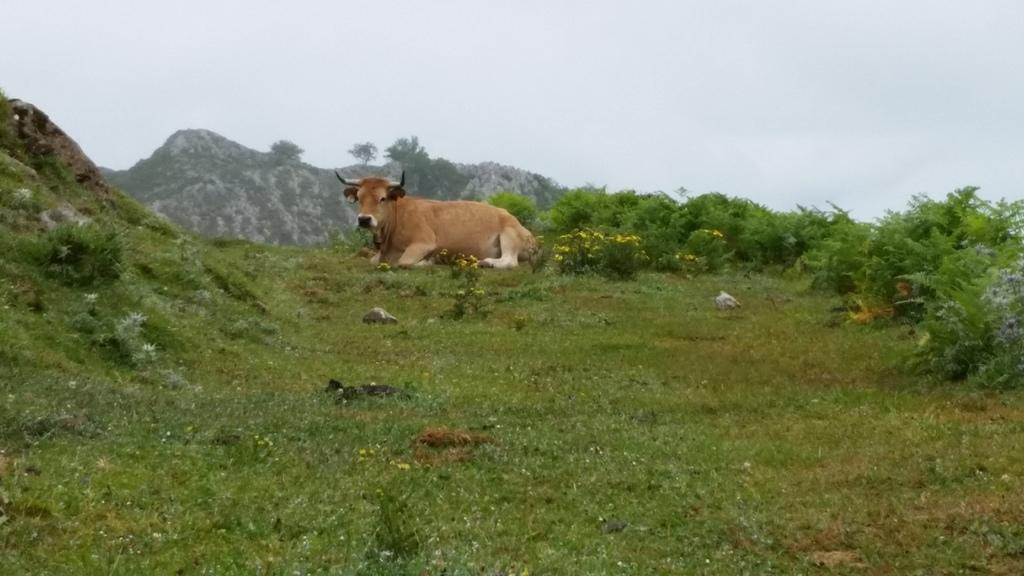What animal is sitting in the center of the image? There is a cow sitting in the center of the image. What type of vegetation is present at the bottom of the image? Grass is present at the bottom of the image. What other types of vegetation can be seen in the image? Flowers and plants are visible in the image. What can be seen in the background of the image? Hills and the sky are visible in the background of the image. What type of wealth is being displayed on the tray in the image? There is no tray or wealth present in the image; it features a cow sitting in a natural setting. 